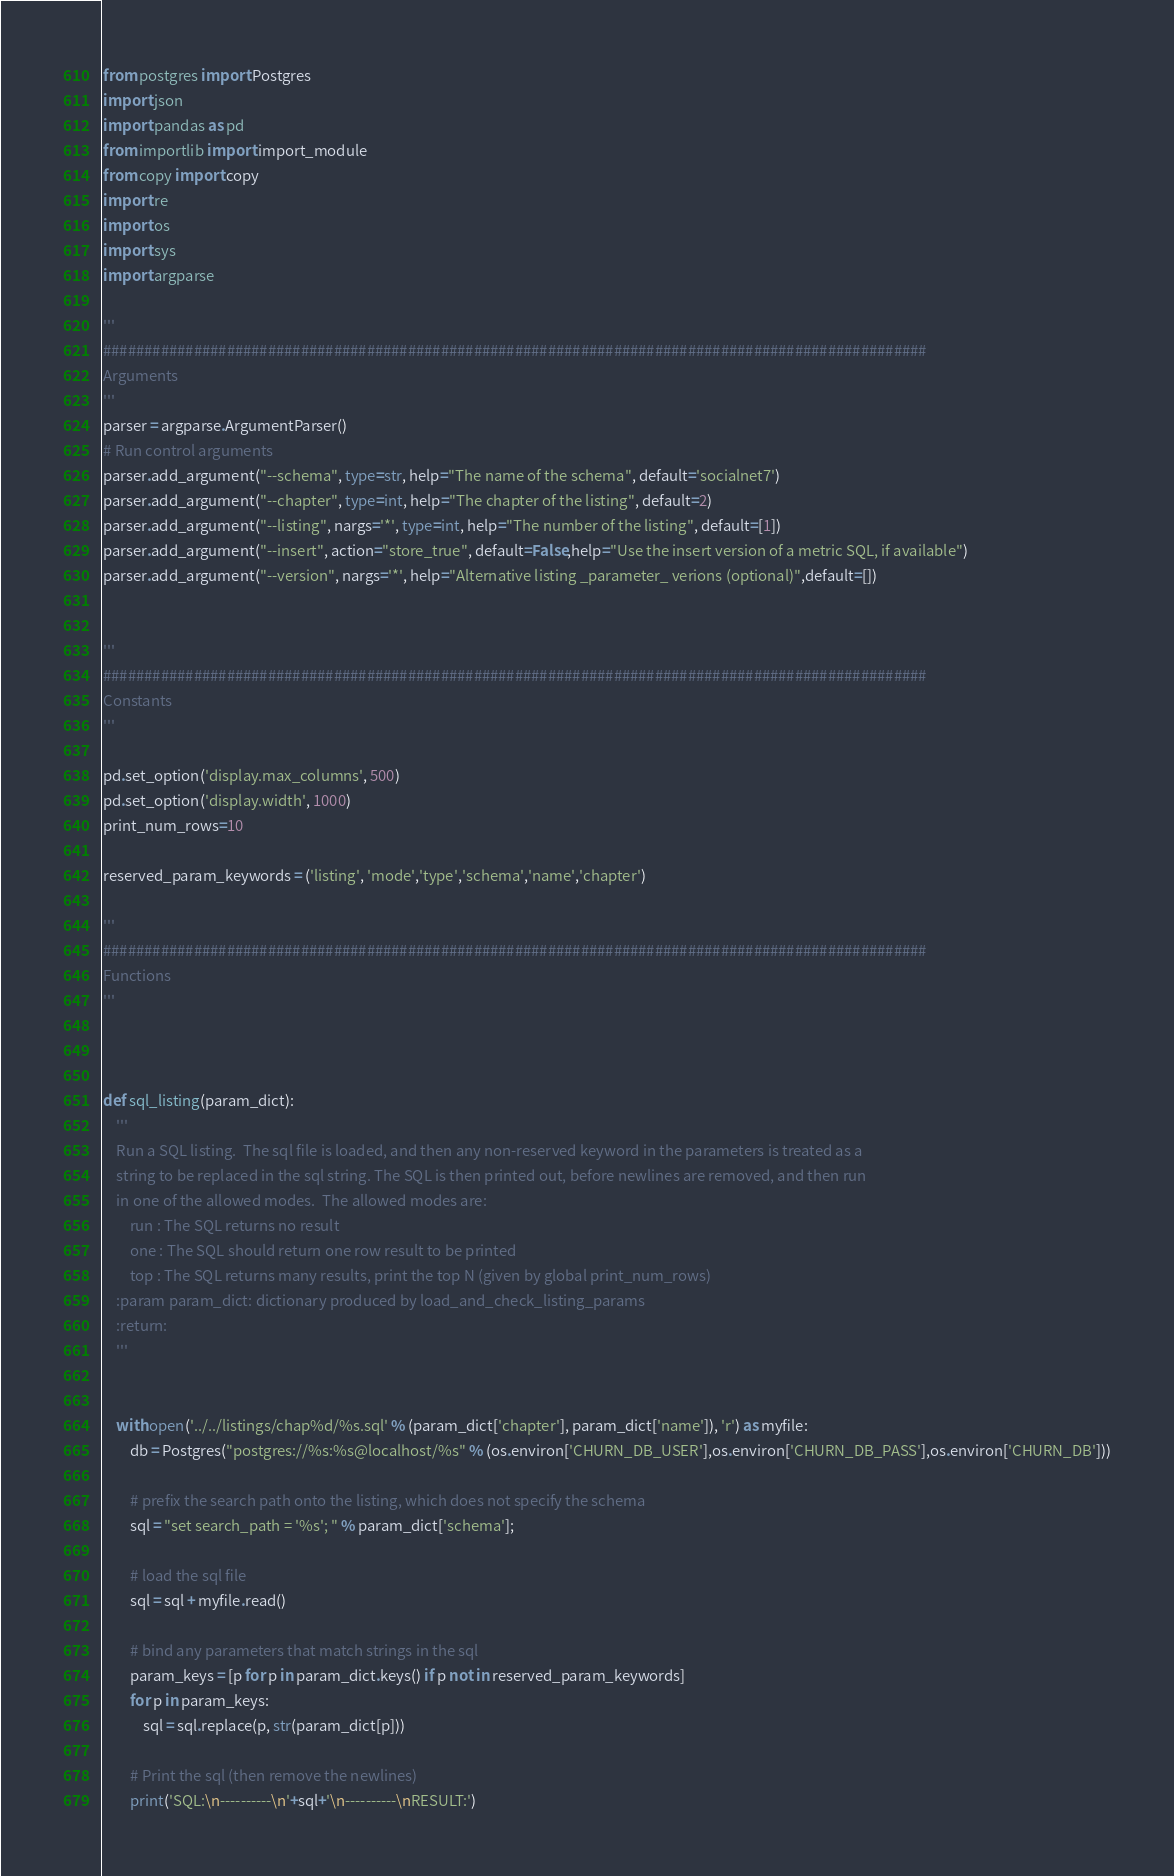<code> <loc_0><loc_0><loc_500><loc_500><_Python_>from postgres import Postgres
import json
import pandas as pd
from importlib import import_module
from copy import copy
import re
import os
import sys
import argparse

'''
####################################################################################################
Arguments
'''
parser = argparse.ArgumentParser()
# Run control arguments
parser.add_argument("--schema", type=str, help="The name of the schema", default='socialnet7')
parser.add_argument("--chapter", type=int, help="The chapter of the listing", default=2)
parser.add_argument("--listing", nargs='*', type=int, help="The number of the listing", default=[1])
parser.add_argument("--insert", action="store_true", default=False,help="Use the insert version of a metric SQL, if available")
parser.add_argument("--version", nargs='*', help="Alternative listing _parameter_ verions (optional)",default=[])


'''
####################################################################################################
Constants
'''

pd.set_option('display.max_columns', 500)
pd.set_option('display.width', 1000)
print_num_rows=10

reserved_param_keywords = ('listing', 'mode','type','schema','name','chapter')

'''
####################################################################################################
Functions
'''



def sql_listing(param_dict):
    '''
    Run a SQL listing.  The sql file is loaded, and then any non-reserved keyword in the parameters is treated as a
    string to be replaced in the sql string. The SQL is then printed out, before newlines are removed, and then run
    in one of the allowed modes.  The allowed modes are:
        run : The SQL returns no result
        one : The SQL should return one row result to be printed
        top : The SQL returns many results, print the top N (given by global print_num_rows)
    :param param_dict: dictionary produced by load_and_check_listing_params
    :return:
    '''


    with open('../../listings/chap%d/%s.sql' % (param_dict['chapter'], param_dict['name']), 'r') as myfile:
        db = Postgres("postgres://%s:%s@localhost/%s" % (os.environ['CHURN_DB_USER'],os.environ['CHURN_DB_PASS'],os.environ['CHURN_DB']))

        # prefix the search path onto the listing, which does not specify the schema
        sql = "set search_path = '%s'; " % param_dict['schema'];

        # load the sql file
        sql = sql + myfile.read()

        # bind any parameters that match strings in the sql
        param_keys = [p for p in param_dict.keys() if p not in reserved_param_keywords]
        for p in param_keys:
            sql = sql.replace(p, str(param_dict[p]))

        # Print the sql (then remove the newlines)
        print('SQL:\n----------\n'+sql+'\n----------\nRESULT:')</code> 